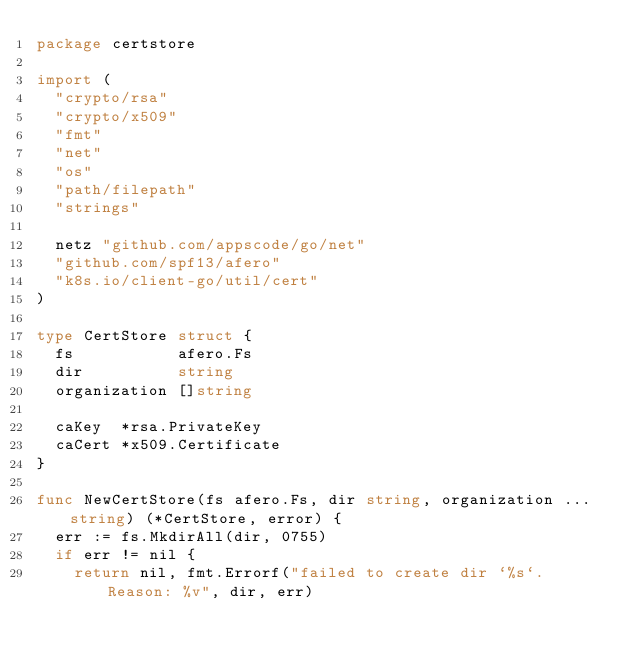Convert code to text. <code><loc_0><loc_0><loc_500><loc_500><_Go_>package certstore

import (
	"crypto/rsa"
	"crypto/x509"
	"fmt"
	"net"
	"os"
	"path/filepath"
	"strings"

	netz "github.com/appscode/go/net"
	"github.com/spf13/afero"
	"k8s.io/client-go/util/cert"
)

type CertStore struct {
	fs           afero.Fs
	dir          string
	organization []string

	caKey  *rsa.PrivateKey
	caCert *x509.Certificate
}

func NewCertStore(fs afero.Fs, dir string, organization ...string) (*CertStore, error) {
	err := fs.MkdirAll(dir, 0755)
	if err != nil {
		return nil, fmt.Errorf("failed to create dir `%s`. Reason: %v", dir, err)</code> 